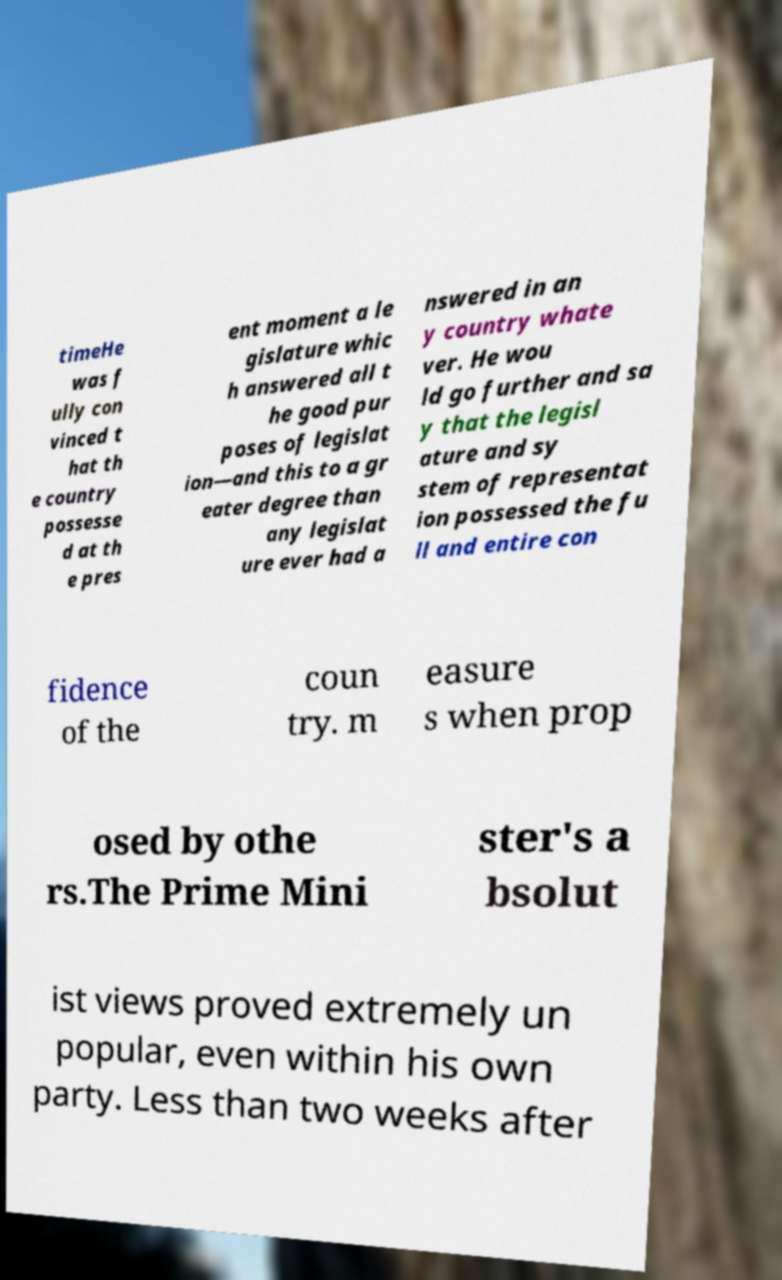Please read and relay the text visible in this image. What does it say? timeHe was f ully con vinced t hat th e country possesse d at th e pres ent moment a le gislature whic h answered all t he good pur poses of legislat ion—and this to a gr eater degree than any legislat ure ever had a nswered in an y country whate ver. He wou ld go further and sa y that the legisl ature and sy stem of representat ion possessed the fu ll and entire con fidence of the coun try. m easure s when prop osed by othe rs.The Prime Mini ster's a bsolut ist views proved extremely un popular, even within his own party. Less than two weeks after 